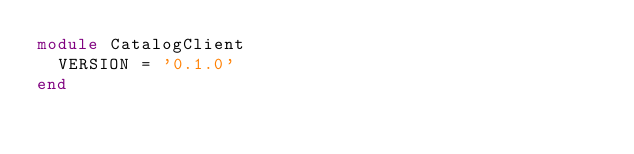<code> <loc_0><loc_0><loc_500><loc_500><_Ruby_>module CatalogClient
  VERSION = '0.1.0'
end
</code> 